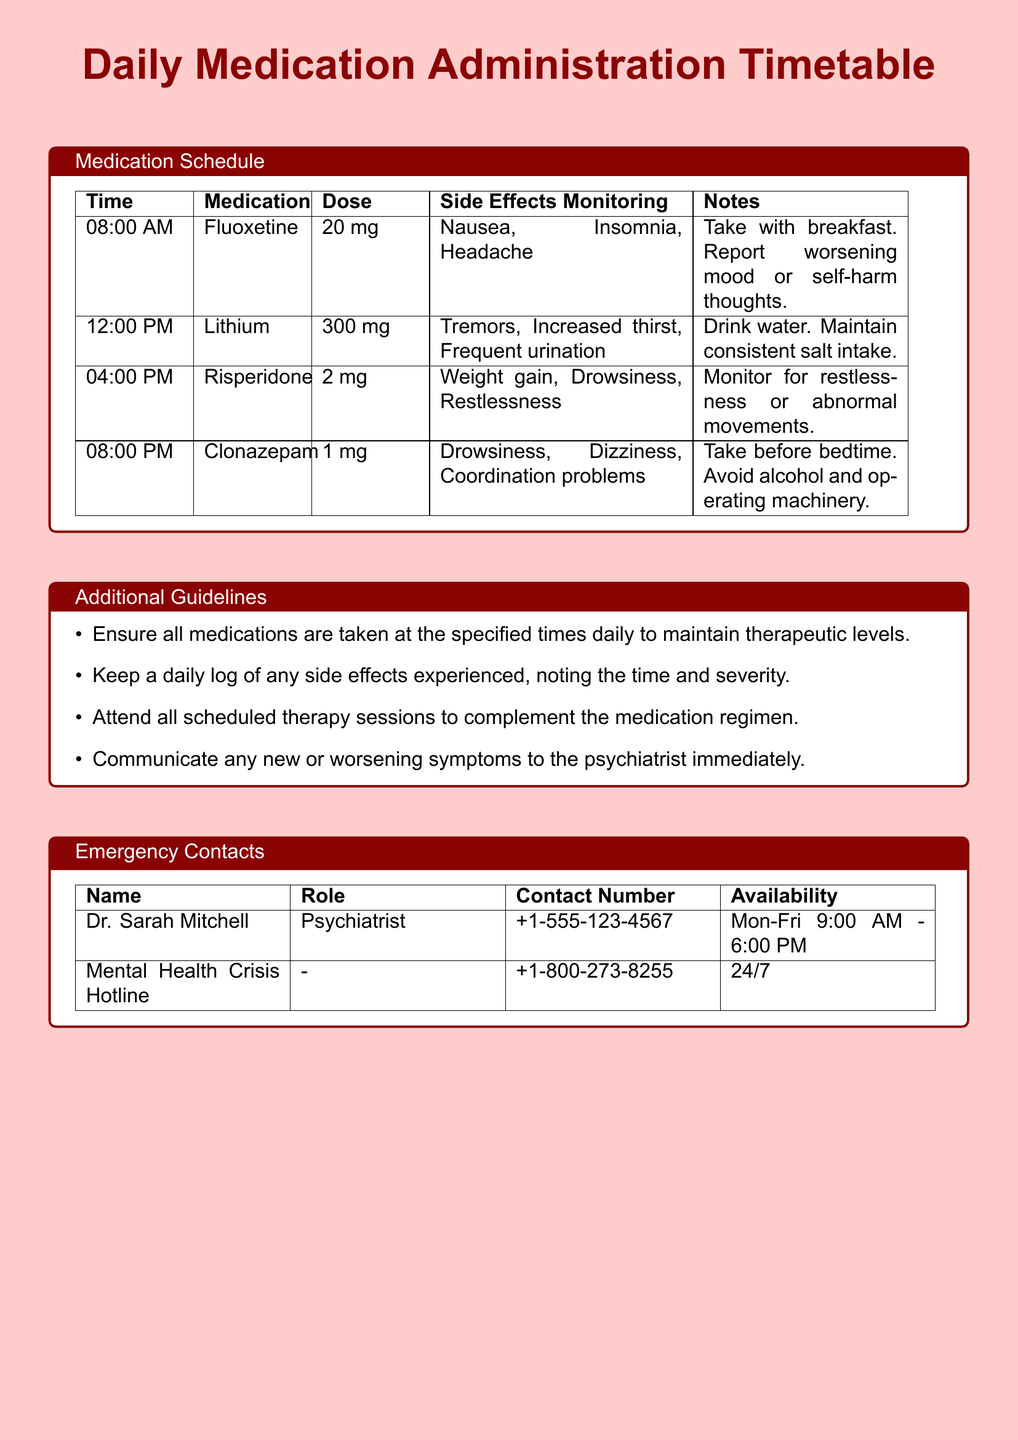What time is Fluoxetine administered? The timetable shows that Fluoxetine is administered at 08:00 AM.
Answer: 08:00 AM How much Lithium is taken daily? The document states that the dosage for Lithium is 300 mg at 12:00 PM.
Answer: 300 mg What side effect should be monitored for Clonazepam? The schedule indicates that drowsiness is a side effect that needs monitoring for Clonazepam.
Answer: Drowsiness What is the purpose of keeping a daily log? The additional guidelines suggest that a daily log is for noting any side effects experienced.
Answer: Side effects Who is the psychiatrist listed in the emergency contacts? The document specifies Dr. Sarah Mitchell as the psychiatrist.
Answer: Dr. Sarah Mitchell What time is the last medication of the day? According to the timetable, the last medication administered is at 08:00 PM.
Answer: 08:00 PM What should be done if symptoms worsen? The additional guidelines advise to communicate any new or worsening symptoms to the psychiatrist immediately.
Answer: Communicate to psychiatrist What medication should be taken before bedtime? The document indicates that Clonazepam should be taken before bedtime.
Answer: Clonazepam 